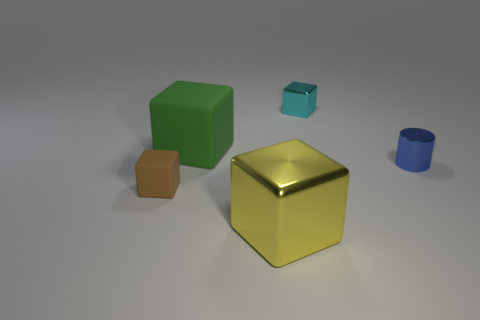Is there any other thing that is the same shape as the blue thing?
Provide a succinct answer. No. Are there more tiny things that are on the left side of the big green matte object than tiny cyan rubber objects?
Keep it short and to the point. Yes. How many blue shiny objects are to the left of the tiny brown rubber block?
Your answer should be very brief. 0. Is there a blue object that has the same size as the brown block?
Offer a very short reply. Yes. There is a small rubber object that is the same shape as the big yellow thing; what color is it?
Give a very brief answer. Brown. There is a matte thing that is behind the small rubber cube; is it the same size as the metallic block that is behind the large yellow metallic thing?
Ensure brevity in your answer.  No. Is there a big green object that has the same shape as the yellow object?
Keep it short and to the point. Yes. Are there the same number of blue cylinders that are right of the blue object and tiny yellow metal things?
Keep it short and to the point. Yes. There is a blue shiny cylinder; does it have the same size as the shiny cube that is behind the large green thing?
Provide a succinct answer. Yes. How many big yellow cubes are the same material as the small blue thing?
Make the answer very short. 1. 